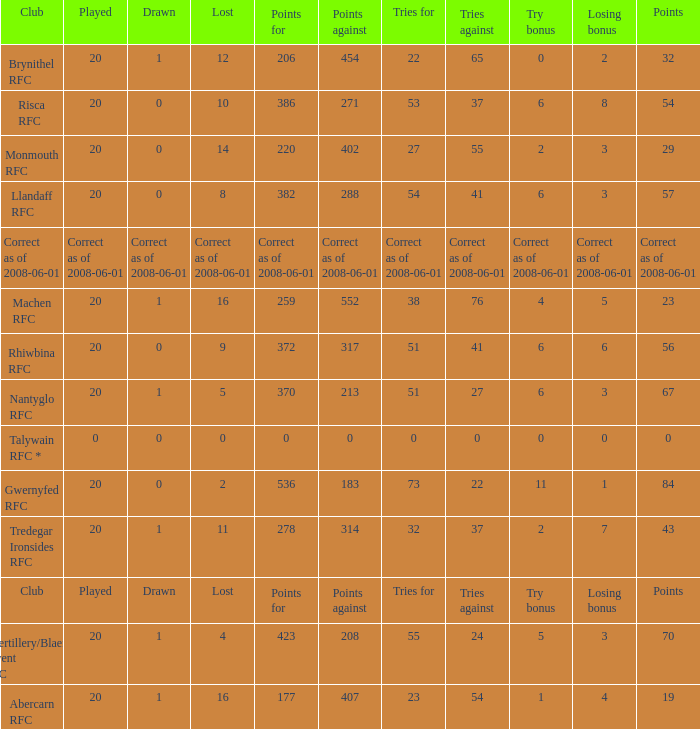If the points were 0, what was the losing bonus? 0.0. 